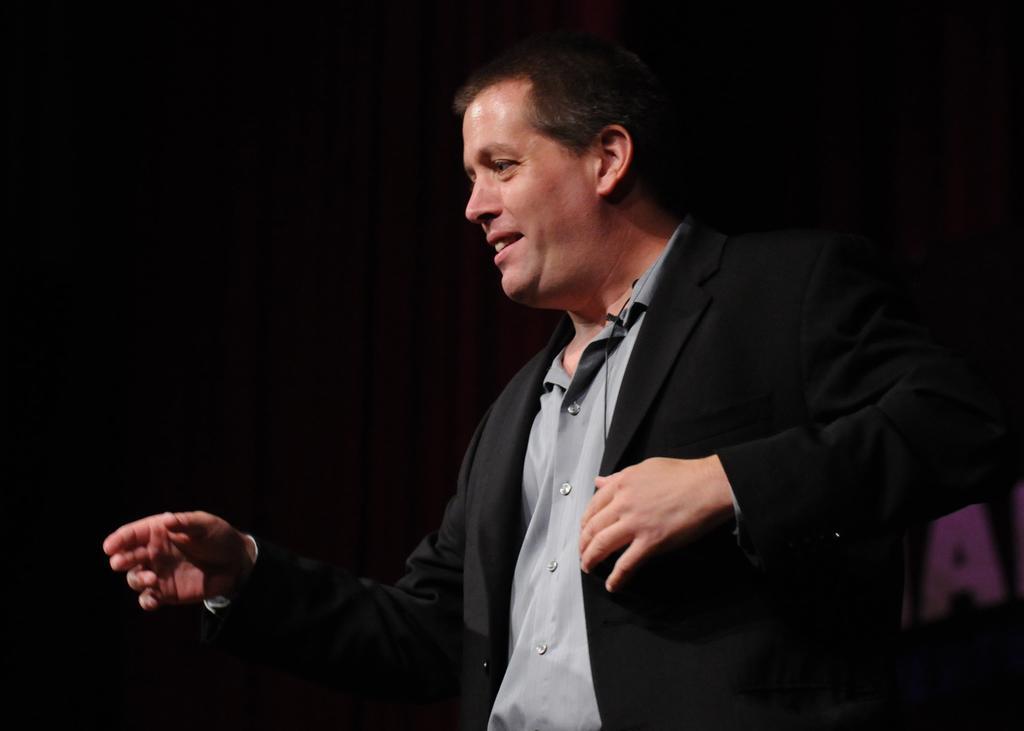Could you give a brief overview of what you see in this image? In the image there is a man with black suit and grey shirt standing and the background is totally dark. 